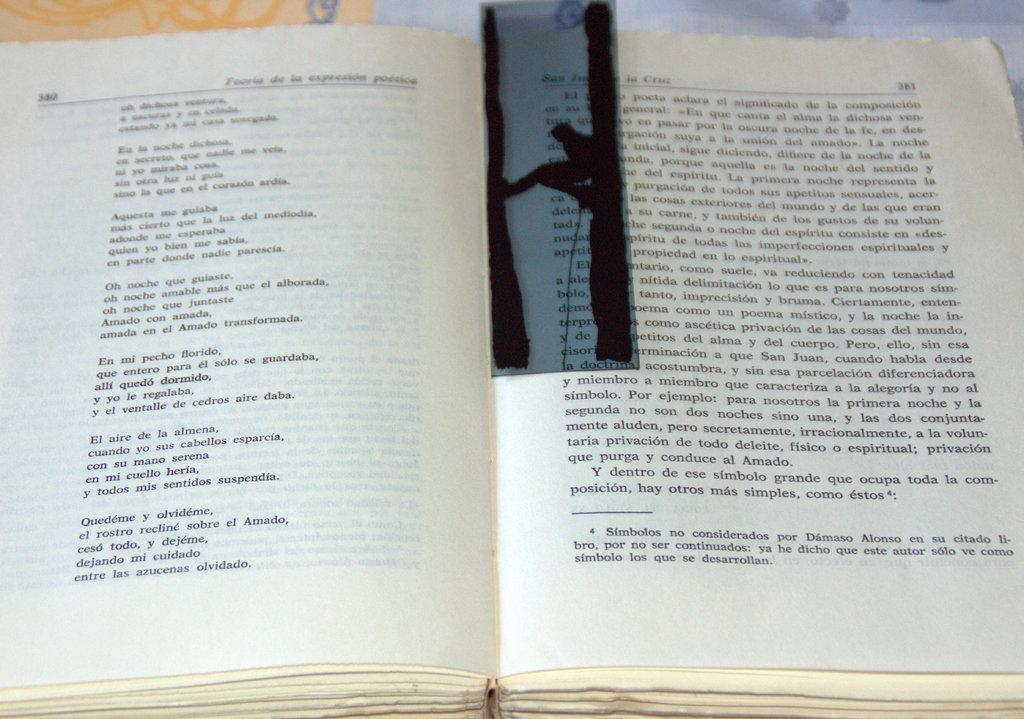What is the main object in the image? There is an open book in the image. What is placed on top of the open book? There is an x-ray filter placed on top of the book. What type of story is being told by the beetle in the image? There is no beetle present in the image, so no story can be told by a beetle. 